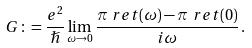Convert formula to latex. <formula><loc_0><loc_0><loc_500><loc_500>G & \colon = \frac { e ^ { 2 } } { \hslash } \lim _ { \omega \to 0 } \frac { \pi _ { \ } r e t ( \omega ) - \pi _ { \ } r e t ( 0 ) } { i \omega } \, .</formula> 